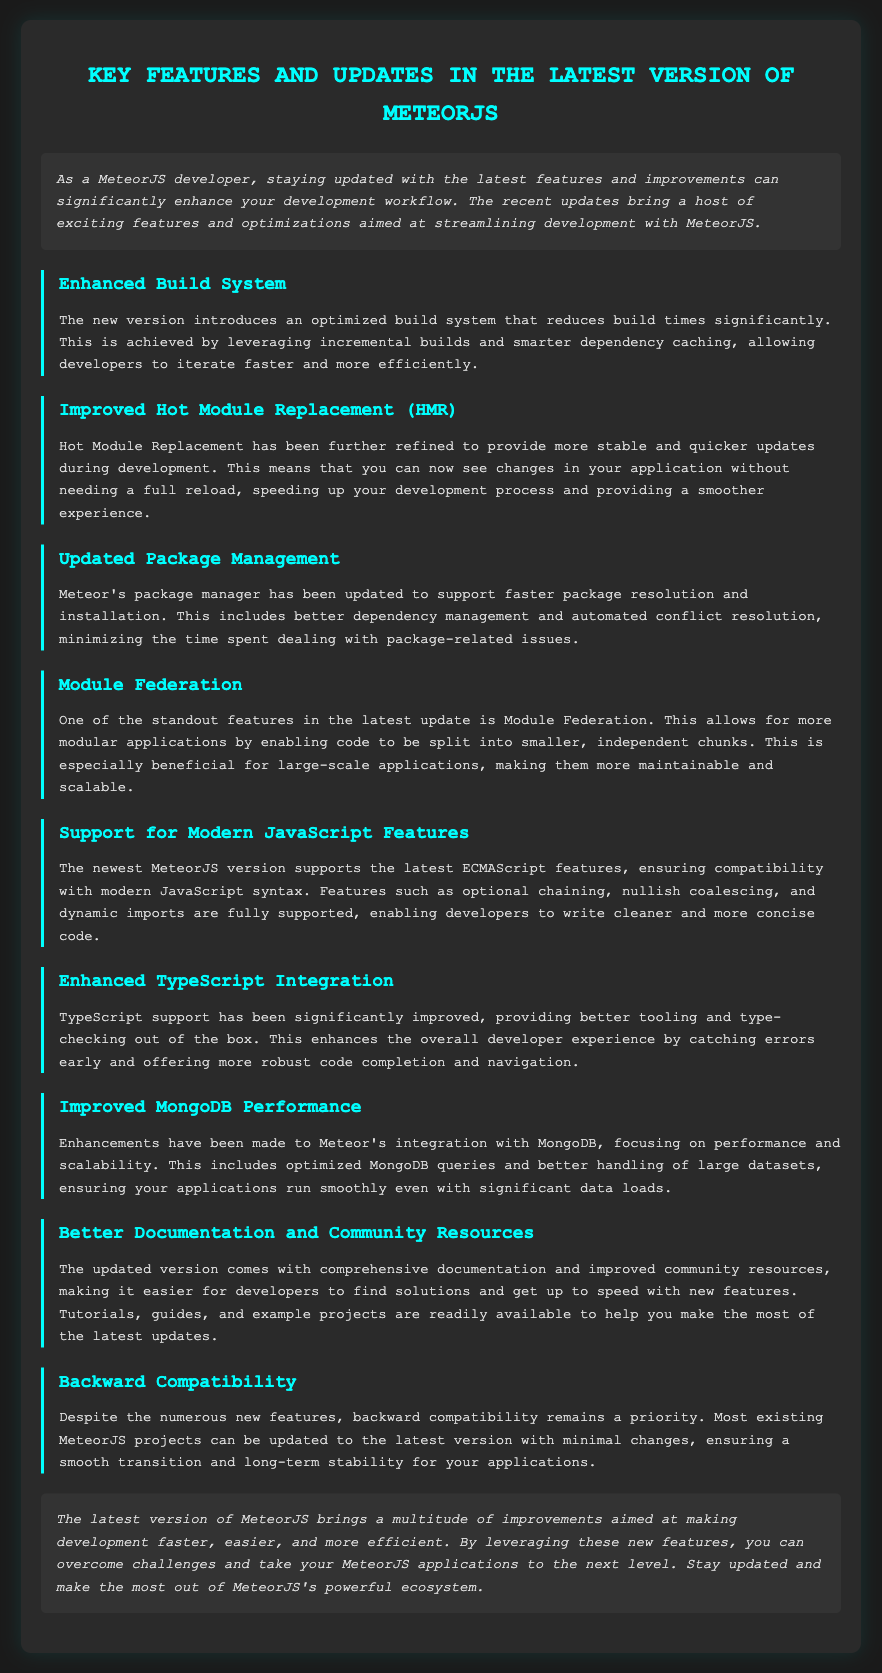What is the main purpose of the latest updates in MeteorJS? The main purpose is to enhance development workflow by introducing exciting features and optimizations.
Answer: Enhance development workflow What feature allows for modular applications in MeteorJS? Module Federation is the feature that enables more modular applications by splitting code into smaller chunks.
Answer: Module Federation Which new JavaScript features are supported in the latest version? The latest version supports ECMAScript features like optional chaining, nullish coalescing, and dynamic imports.
Answer: Optional chaining, nullish coalescing, dynamic imports What improvement has been made to the build system? The new version introduces an optimized build system that reduces build times significantly.
Answer: Reduced build times How has TypeScript integration been improved? TypeScript support has been improved by providing better tooling and type-checking out of the box.
Answer: Better tooling and type-checking What is the focus of the enhancements made to MongoDB performance? The enhancements focus on performance and scalability, specifically optimized queries and handling large datasets.
Answer: Performance and scalability What is prioritized despite the new features? Backward compatibility remains a priority to ensure a smooth transition for existing projects.
Answer: Backward compatibility What type of resources have been updated for developers? Comprehensive documentation and improved community resources have been updated for developers.
Answer: Comprehensive documentation and community resources How has Hot Module Replacement (HMR) been refined? HMR has been refined to provide more stable and quicker updates during development.
Answer: More stable and quicker updates 